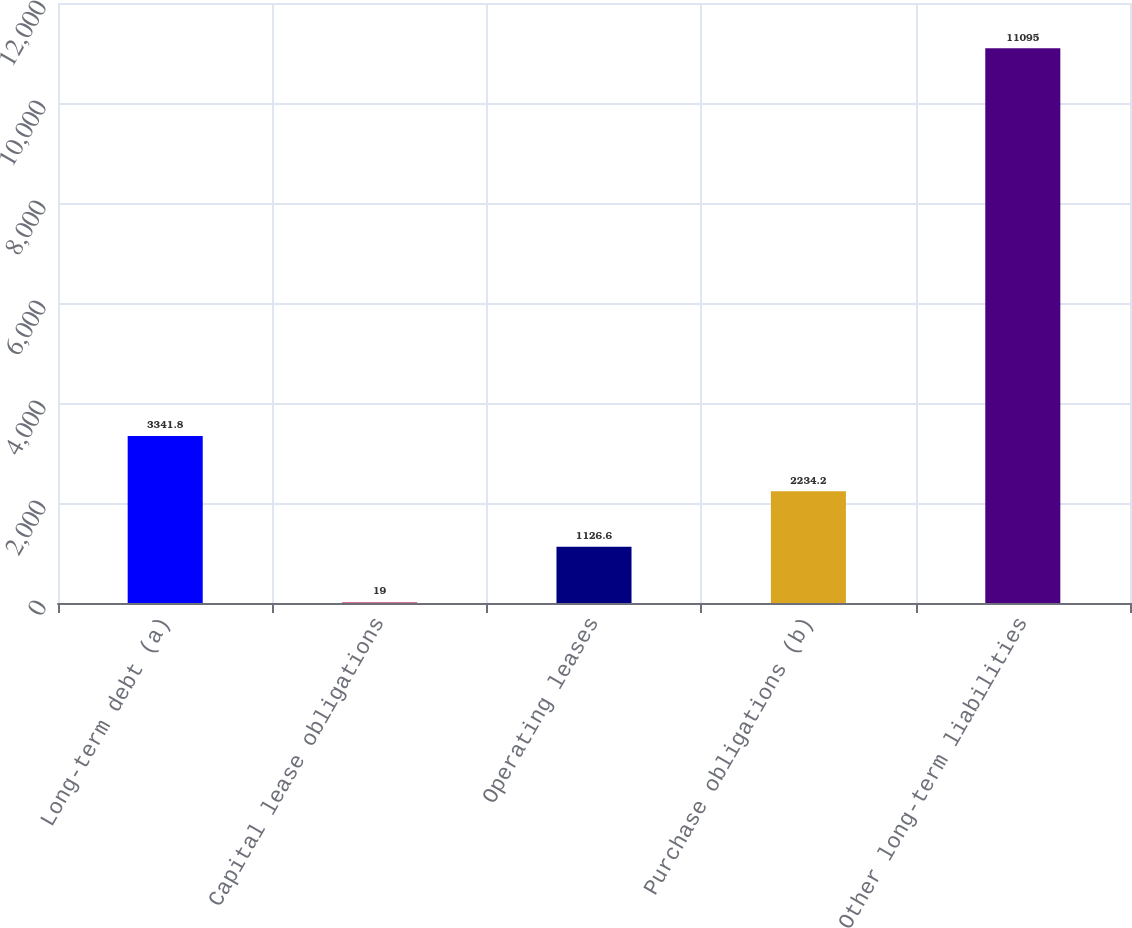Convert chart to OTSL. <chart><loc_0><loc_0><loc_500><loc_500><bar_chart><fcel>Long-term debt (a)<fcel>Capital lease obligations<fcel>Operating leases<fcel>Purchase obligations (b)<fcel>Other long-term liabilities<nl><fcel>3341.8<fcel>19<fcel>1126.6<fcel>2234.2<fcel>11095<nl></chart> 